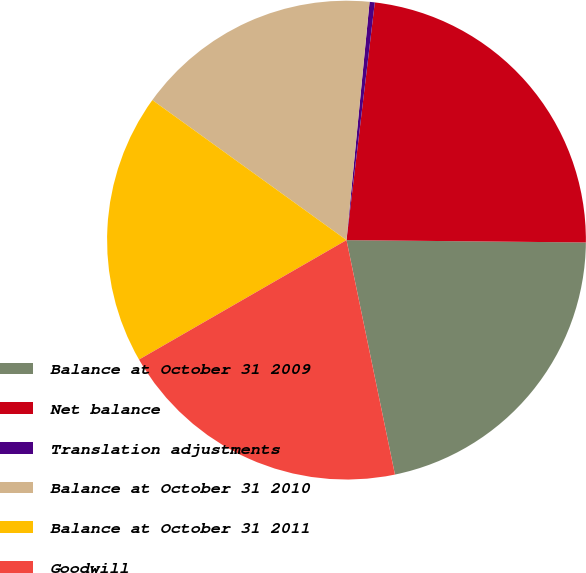Convert chart to OTSL. <chart><loc_0><loc_0><loc_500><loc_500><pie_chart><fcel>Balance at October 31 2009<fcel>Net balance<fcel>Translation adjustments<fcel>Balance at October 31 2010<fcel>Balance at October 31 2011<fcel>Goodwill<nl><fcel>21.6%<fcel>23.27%<fcel>0.35%<fcel>16.59%<fcel>18.26%<fcel>19.93%<nl></chart> 